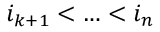Convert formula to latex. <formula><loc_0><loc_0><loc_500><loc_500>i _ { k + 1 } < \dots < i _ { n }</formula> 